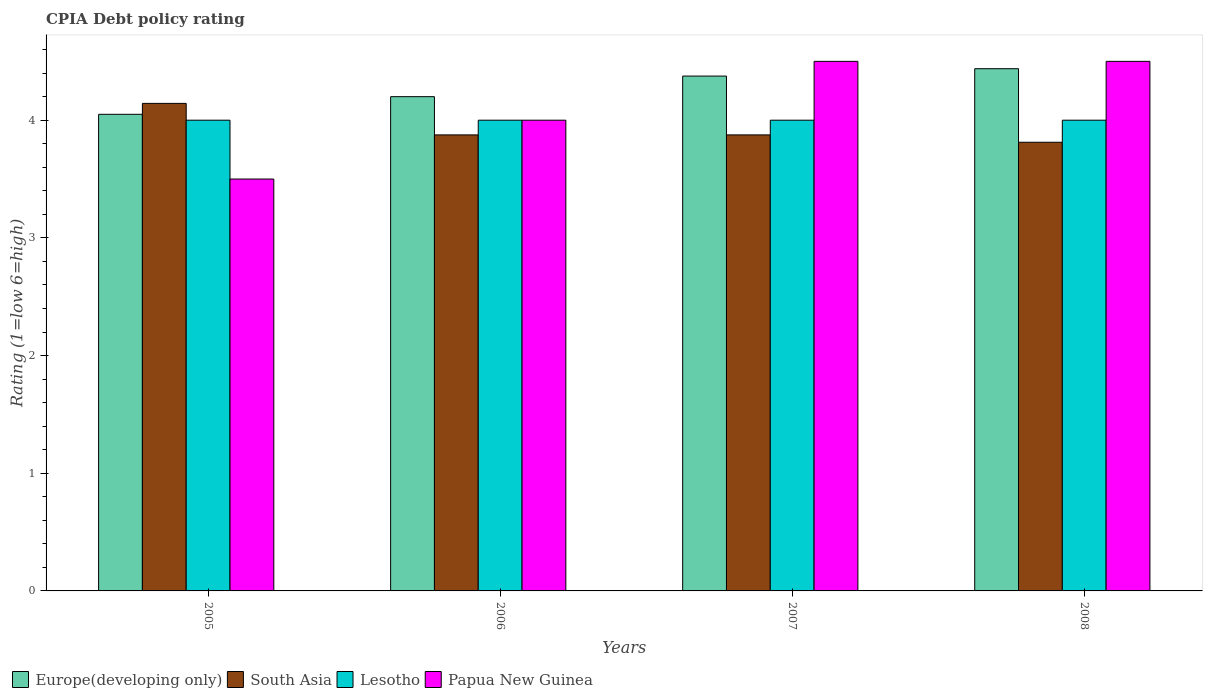Are the number of bars per tick equal to the number of legend labels?
Provide a succinct answer. Yes. Are the number of bars on each tick of the X-axis equal?
Keep it short and to the point. Yes. How many bars are there on the 2nd tick from the left?
Keep it short and to the point. 4. What is the label of the 2nd group of bars from the left?
Provide a succinct answer. 2006. In how many cases, is the number of bars for a given year not equal to the number of legend labels?
Offer a very short reply. 0. What is the CPIA rating in South Asia in 2008?
Keep it short and to the point. 3.81. Across all years, what is the maximum CPIA rating in Europe(developing only)?
Your answer should be very brief. 4.44. Across all years, what is the minimum CPIA rating in Europe(developing only)?
Provide a succinct answer. 4.05. In which year was the CPIA rating in Papua New Guinea maximum?
Your response must be concise. 2007. What is the total CPIA rating in Lesotho in the graph?
Ensure brevity in your answer.  16. What is the difference between the CPIA rating in Europe(developing only) in 2005 and that in 2007?
Your response must be concise. -0.33. What is the difference between the CPIA rating in South Asia in 2008 and the CPIA rating in Europe(developing only) in 2006?
Provide a succinct answer. -0.39. What is the average CPIA rating in Papua New Guinea per year?
Offer a terse response. 4.12. In the year 2006, what is the difference between the CPIA rating in Europe(developing only) and CPIA rating in Papua New Guinea?
Offer a terse response. 0.2. What is the ratio of the CPIA rating in South Asia in 2005 to that in 2006?
Offer a terse response. 1.07. Is the CPIA rating in South Asia in 2006 less than that in 2007?
Provide a succinct answer. No. What is the difference between the highest and the second highest CPIA rating in South Asia?
Your response must be concise. 0.27. What is the difference between the highest and the lowest CPIA rating in South Asia?
Provide a short and direct response. 0.33. What does the 1st bar from the left in 2005 represents?
Make the answer very short. Europe(developing only). What does the 1st bar from the right in 2005 represents?
Provide a succinct answer. Papua New Guinea. How many bars are there?
Keep it short and to the point. 16. Are all the bars in the graph horizontal?
Ensure brevity in your answer.  No. Are the values on the major ticks of Y-axis written in scientific E-notation?
Provide a succinct answer. No. Does the graph contain any zero values?
Provide a succinct answer. No. Where does the legend appear in the graph?
Provide a short and direct response. Bottom left. How many legend labels are there?
Your answer should be very brief. 4. What is the title of the graph?
Your answer should be very brief. CPIA Debt policy rating. Does "St. Martin (French part)" appear as one of the legend labels in the graph?
Provide a short and direct response. No. What is the Rating (1=low 6=high) of Europe(developing only) in 2005?
Your response must be concise. 4.05. What is the Rating (1=low 6=high) in South Asia in 2005?
Your answer should be very brief. 4.14. What is the Rating (1=low 6=high) of Papua New Guinea in 2005?
Ensure brevity in your answer.  3.5. What is the Rating (1=low 6=high) in Europe(developing only) in 2006?
Your answer should be compact. 4.2. What is the Rating (1=low 6=high) in South Asia in 2006?
Offer a very short reply. 3.88. What is the Rating (1=low 6=high) of Papua New Guinea in 2006?
Your response must be concise. 4. What is the Rating (1=low 6=high) in Europe(developing only) in 2007?
Your response must be concise. 4.38. What is the Rating (1=low 6=high) in South Asia in 2007?
Make the answer very short. 3.88. What is the Rating (1=low 6=high) in Lesotho in 2007?
Give a very brief answer. 4. What is the Rating (1=low 6=high) of Europe(developing only) in 2008?
Make the answer very short. 4.44. What is the Rating (1=low 6=high) in South Asia in 2008?
Ensure brevity in your answer.  3.81. What is the Rating (1=low 6=high) in Lesotho in 2008?
Give a very brief answer. 4. What is the Rating (1=low 6=high) in Papua New Guinea in 2008?
Provide a succinct answer. 4.5. Across all years, what is the maximum Rating (1=low 6=high) of Europe(developing only)?
Offer a terse response. 4.44. Across all years, what is the maximum Rating (1=low 6=high) in South Asia?
Provide a short and direct response. 4.14. Across all years, what is the maximum Rating (1=low 6=high) in Lesotho?
Offer a very short reply. 4. Across all years, what is the maximum Rating (1=low 6=high) in Papua New Guinea?
Give a very brief answer. 4.5. Across all years, what is the minimum Rating (1=low 6=high) of Europe(developing only)?
Offer a terse response. 4.05. Across all years, what is the minimum Rating (1=low 6=high) of South Asia?
Offer a terse response. 3.81. Across all years, what is the minimum Rating (1=low 6=high) in Lesotho?
Make the answer very short. 4. What is the total Rating (1=low 6=high) in Europe(developing only) in the graph?
Ensure brevity in your answer.  17.06. What is the total Rating (1=low 6=high) in South Asia in the graph?
Offer a terse response. 15.71. What is the total Rating (1=low 6=high) in Papua New Guinea in the graph?
Ensure brevity in your answer.  16.5. What is the difference between the Rating (1=low 6=high) in Europe(developing only) in 2005 and that in 2006?
Offer a very short reply. -0.15. What is the difference between the Rating (1=low 6=high) in South Asia in 2005 and that in 2006?
Your answer should be compact. 0.27. What is the difference between the Rating (1=low 6=high) in Europe(developing only) in 2005 and that in 2007?
Your response must be concise. -0.33. What is the difference between the Rating (1=low 6=high) of South Asia in 2005 and that in 2007?
Offer a very short reply. 0.27. What is the difference between the Rating (1=low 6=high) in Lesotho in 2005 and that in 2007?
Offer a terse response. 0. What is the difference between the Rating (1=low 6=high) in Papua New Guinea in 2005 and that in 2007?
Make the answer very short. -1. What is the difference between the Rating (1=low 6=high) in Europe(developing only) in 2005 and that in 2008?
Provide a succinct answer. -0.39. What is the difference between the Rating (1=low 6=high) in South Asia in 2005 and that in 2008?
Keep it short and to the point. 0.33. What is the difference between the Rating (1=low 6=high) of Papua New Guinea in 2005 and that in 2008?
Give a very brief answer. -1. What is the difference between the Rating (1=low 6=high) of Europe(developing only) in 2006 and that in 2007?
Provide a short and direct response. -0.17. What is the difference between the Rating (1=low 6=high) in South Asia in 2006 and that in 2007?
Ensure brevity in your answer.  0. What is the difference between the Rating (1=low 6=high) in Papua New Guinea in 2006 and that in 2007?
Keep it short and to the point. -0.5. What is the difference between the Rating (1=low 6=high) of Europe(developing only) in 2006 and that in 2008?
Provide a short and direct response. -0.24. What is the difference between the Rating (1=low 6=high) of South Asia in 2006 and that in 2008?
Your answer should be very brief. 0.06. What is the difference between the Rating (1=low 6=high) of Lesotho in 2006 and that in 2008?
Offer a very short reply. 0. What is the difference between the Rating (1=low 6=high) of Papua New Guinea in 2006 and that in 2008?
Offer a terse response. -0.5. What is the difference between the Rating (1=low 6=high) of Europe(developing only) in 2007 and that in 2008?
Provide a succinct answer. -0.06. What is the difference between the Rating (1=low 6=high) of South Asia in 2007 and that in 2008?
Provide a succinct answer. 0.06. What is the difference between the Rating (1=low 6=high) in Papua New Guinea in 2007 and that in 2008?
Provide a short and direct response. 0. What is the difference between the Rating (1=low 6=high) of Europe(developing only) in 2005 and the Rating (1=low 6=high) of South Asia in 2006?
Your answer should be compact. 0.17. What is the difference between the Rating (1=low 6=high) in Europe(developing only) in 2005 and the Rating (1=low 6=high) in Lesotho in 2006?
Provide a short and direct response. 0.05. What is the difference between the Rating (1=low 6=high) in Europe(developing only) in 2005 and the Rating (1=low 6=high) in Papua New Guinea in 2006?
Your answer should be compact. 0.05. What is the difference between the Rating (1=low 6=high) of South Asia in 2005 and the Rating (1=low 6=high) of Lesotho in 2006?
Give a very brief answer. 0.14. What is the difference between the Rating (1=low 6=high) of South Asia in 2005 and the Rating (1=low 6=high) of Papua New Guinea in 2006?
Provide a succinct answer. 0.14. What is the difference between the Rating (1=low 6=high) of Lesotho in 2005 and the Rating (1=low 6=high) of Papua New Guinea in 2006?
Offer a terse response. 0. What is the difference between the Rating (1=low 6=high) in Europe(developing only) in 2005 and the Rating (1=low 6=high) in South Asia in 2007?
Offer a very short reply. 0.17. What is the difference between the Rating (1=low 6=high) of Europe(developing only) in 2005 and the Rating (1=low 6=high) of Papua New Guinea in 2007?
Your answer should be compact. -0.45. What is the difference between the Rating (1=low 6=high) of South Asia in 2005 and the Rating (1=low 6=high) of Lesotho in 2007?
Ensure brevity in your answer.  0.14. What is the difference between the Rating (1=low 6=high) of South Asia in 2005 and the Rating (1=low 6=high) of Papua New Guinea in 2007?
Ensure brevity in your answer.  -0.36. What is the difference between the Rating (1=low 6=high) of Europe(developing only) in 2005 and the Rating (1=low 6=high) of South Asia in 2008?
Ensure brevity in your answer.  0.24. What is the difference between the Rating (1=low 6=high) of Europe(developing only) in 2005 and the Rating (1=low 6=high) of Papua New Guinea in 2008?
Offer a very short reply. -0.45. What is the difference between the Rating (1=low 6=high) in South Asia in 2005 and the Rating (1=low 6=high) in Lesotho in 2008?
Offer a very short reply. 0.14. What is the difference between the Rating (1=low 6=high) in South Asia in 2005 and the Rating (1=low 6=high) in Papua New Guinea in 2008?
Your answer should be very brief. -0.36. What is the difference between the Rating (1=low 6=high) in Lesotho in 2005 and the Rating (1=low 6=high) in Papua New Guinea in 2008?
Make the answer very short. -0.5. What is the difference between the Rating (1=low 6=high) in Europe(developing only) in 2006 and the Rating (1=low 6=high) in South Asia in 2007?
Offer a very short reply. 0.33. What is the difference between the Rating (1=low 6=high) of Europe(developing only) in 2006 and the Rating (1=low 6=high) of Papua New Guinea in 2007?
Provide a short and direct response. -0.3. What is the difference between the Rating (1=low 6=high) in South Asia in 2006 and the Rating (1=low 6=high) in Lesotho in 2007?
Make the answer very short. -0.12. What is the difference between the Rating (1=low 6=high) of South Asia in 2006 and the Rating (1=low 6=high) of Papua New Guinea in 2007?
Your answer should be compact. -0.62. What is the difference between the Rating (1=low 6=high) of Europe(developing only) in 2006 and the Rating (1=low 6=high) of South Asia in 2008?
Provide a succinct answer. 0.39. What is the difference between the Rating (1=low 6=high) of South Asia in 2006 and the Rating (1=low 6=high) of Lesotho in 2008?
Provide a succinct answer. -0.12. What is the difference between the Rating (1=low 6=high) of South Asia in 2006 and the Rating (1=low 6=high) of Papua New Guinea in 2008?
Offer a terse response. -0.62. What is the difference between the Rating (1=low 6=high) in Lesotho in 2006 and the Rating (1=low 6=high) in Papua New Guinea in 2008?
Your response must be concise. -0.5. What is the difference between the Rating (1=low 6=high) in Europe(developing only) in 2007 and the Rating (1=low 6=high) in South Asia in 2008?
Ensure brevity in your answer.  0.56. What is the difference between the Rating (1=low 6=high) in Europe(developing only) in 2007 and the Rating (1=low 6=high) in Lesotho in 2008?
Ensure brevity in your answer.  0.38. What is the difference between the Rating (1=low 6=high) of Europe(developing only) in 2007 and the Rating (1=low 6=high) of Papua New Guinea in 2008?
Keep it short and to the point. -0.12. What is the difference between the Rating (1=low 6=high) of South Asia in 2007 and the Rating (1=low 6=high) of Lesotho in 2008?
Provide a succinct answer. -0.12. What is the difference between the Rating (1=low 6=high) of South Asia in 2007 and the Rating (1=low 6=high) of Papua New Guinea in 2008?
Offer a very short reply. -0.62. What is the average Rating (1=low 6=high) in Europe(developing only) per year?
Offer a very short reply. 4.27. What is the average Rating (1=low 6=high) of South Asia per year?
Offer a terse response. 3.93. What is the average Rating (1=low 6=high) in Papua New Guinea per year?
Make the answer very short. 4.12. In the year 2005, what is the difference between the Rating (1=low 6=high) of Europe(developing only) and Rating (1=low 6=high) of South Asia?
Offer a very short reply. -0.09. In the year 2005, what is the difference between the Rating (1=low 6=high) in Europe(developing only) and Rating (1=low 6=high) in Lesotho?
Provide a short and direct response. 0.05. In the year 2005, what is the difference between the Rating (1=low 6=high) in Europe(developing only) and Rating (1=low 6=high) in Papua New Guinea?
Give a very brief answer. 0.55. In the year 2005, what is the difference between the Rating (1=low 6=high) of South Asia and Rating (1=low 6=high) of Lesotho?
Provide a short and direct response. 0.14. In the year 2005, what is the difference between the Rating (1=low 6=high) of South Asia and Rating (1=low 6=high) of Papua New Guinea?
Your answer should be very brief. 0.64. In the year 2006, what is the difference between the Rating (1=low 6=high) in Europe(developing only) and Rating (1=low 6=high) in South Asia?
Ensure brevity in your answer.  0.33. In the year 2006, what is the difference between the Rating (1=low 6=high) of Europe(developing only) and Rating (1=low 6=high) of Papua New Guinea?
Give a very brief answer. 0.2. In the year 2006, what is the difference between the Rating (1=low 6=high) in South Asia and Rating (1=low 6=high) in Lesotho?
Your answer should be very brief. -0.12. In the year 2006, what is the difference between the Rating (1=low 6=high) in South Asia and Rating (1=low 6=high) in Papua New Guinea?
Keep it short and to the point. -0.12. In the year 2007, what is the difference between the Rating (1=low 6=high) in Europe(developing only) and Rating (1=low 6=high) in Lesotho?
Make the answer very short. 0.38. In the year 2007, what is the difference between the Rating (1=low 6=high) in Europe(developing only) and Rating (1=low 6=high) in Papua New Guinea?
Offer a very short reply. -0.12. In the year 2007, what is the difference between the Rating (1=low 6=high) of South Asia and Rating (1=low 6=high) of Lesotho?
Ensure brevity in your answer.  -0.12. In the year 2007, what is the difference between the Rating (1=low 6=high) of South Asia and Rating (1=low 6=high) of Papua New Guinea?
Provide a succinct answer. -0.62. In the year 2008, what is the difference between the Rating (1=low 6=high) of Europe(developing only) and Rating (1=low 6=high) of South Asia?
Provide a succinct answer. 0.62. In the year 2008, what is the difference between the Rating (1=low 6=high) of Europe(developing only) and Rating (1=low 6=high) of Lesotho?
Your answer should be compact. 0.44. In the year 2008, what is the difference between the Rating (1=low 6=high) of Europe(developing only) and Rating (1=low 6=high) of Papua New Guinea?
Provide a short and direct response. -0.06. In the year 2008, what is the difference between the Rating (1=low 6=high) of South Asia and Rating (1=low 6=high) of Lesotho?
Your answer should be compact. -0.19. In the year 2008, what is the difference between the Rating (1=low 6=high) in South Asia and Rating (1=low 6=high) in Papua New Guinea?
Provide a short and direct response. -0.69. In the year 2008, what is the difference between the Rating (1=low 6=high) in Lesotho and Rating (1=low 6=high) in Papua New Guinea?
Provide a short and direct response. -0.5. What is the ratio of the Rating (1=low 6=high) of South Asia in 2005 to that in 2006?
Keep it short and to the point. 1.07. What is the ratio of the Rating (1=low 6=high) in Europe(developing only) in 2005 to that in 2007?
Provide a short and direct response. 0.93. What is the ratio of the Rating (1=low 6=high) in South Asia in 2005 to that in 2007?
Your answer should be very brief. 1.07. What is the ratio of the Rating (1=low 6=high) of Lesotho in 2005 to that in 2007?
Offer a terse response. 1. What is the ratio of the Rating (1=low 6=high) in Papua New Guinea in 2005 to that in 2007?
Your answer should be compact. 0.78. What is the ratio of the Rating (1=low 6=high) in Europe(developing only) in 2005 to that in 2008?
Ensure brevity in your answer.  0.91. What is the ratio of the Rating (1=low 6=high) of South Asia in 2005 to that in 2008?
Provide a succinct answer. 1.09. What is the ratio of the Rating (1=low 6=high) in Lesotho in 2005 to that in 2008?
Ensure brevity in your answer.  1. What is the ratio of the Rating (1=low 6=high) in Papua New Guinea in 2005 to that in 2008?
Offer a terse response. 0.78. What is the ratio of the Rating (1=low 6=high) of Europe(developing only) in 2006 to that in 2007?
Make the answer very short. 0.96. What is the ratio of the Rating (1=low 6=high) in Lesotho in 2006 to that in 2007?
Give a very brief answer. 1. What is the ratio of the Rating (1=low 6=high) in Europe(developing only) in 2006 to that in 2008?
Your answer should be compact. 0.95. What is the ratio of the Rating (1=low 6=high) in South Asia in 2006 to that in 2008?
Provide a succinct answer. 1.02. What is the ratio of the Rating (1=low 6=high) in Lesotho in 2006 to that in 2008?
Make the answer very short. 1. What is the ratio of the Rating (1=low 6=high) of Europe(developing only) in 2007 to that in 2008?
Give a very brief answer. 0.99. What is the ratio of the Rating (1=low 6=high) of South Asia in 2007 to that in 2008?
Ensure brevity in your answer.  1.02. What is the ratio of the Rating (1=low 6=high) in Lesotho in 2007 to that in 2008?
Your answer should be very brief. 1. What is the ratio of the Rating (1=low 6=high) in Papua New Guinea in 2007 to that in 2008?
Your answer should be compact. 1. What is the difference between the highest and the second highest Rating (1=low 6=high) of Europe(developing only)?
Offer a very short reply. 0.06. What is the difference between the highest and the second highest Rating (1=low 6=high) of South Asia?
Offer a terse response. 0.27. What is the difference between the highest and the second highest Rating (1=low 6=high) in Lesotho?
Your response must be concise. 0. What is the difference between the highest and the lowest Rating (1=low 6=high) of Europe(developing only)?
Offer a very short reply. 0.39. What is the difference between the highest and the lowest Rating (1=low 6=high) of South Asia?
Provide a short and direct response. 0.33. 